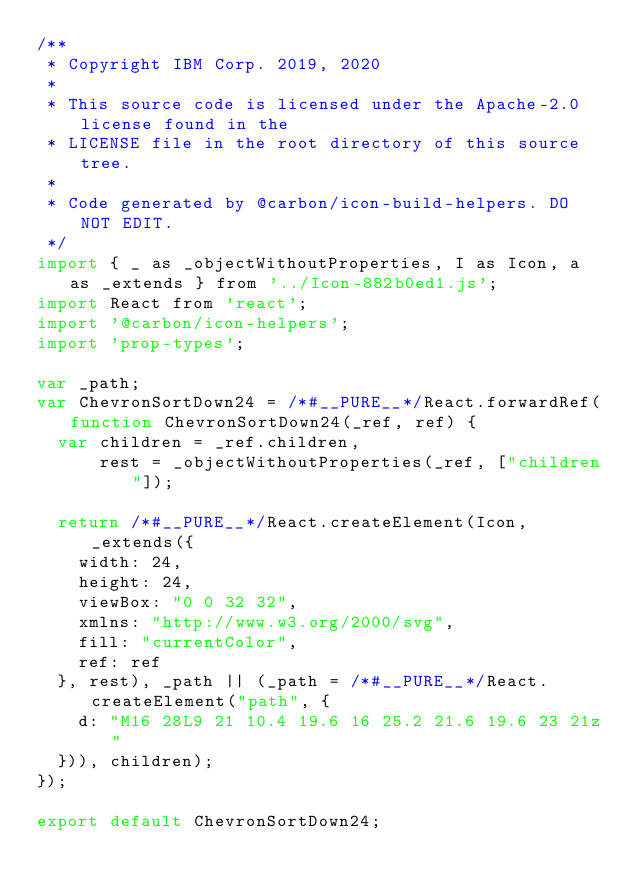Convert code to text. <code><loc_0><loc_0><loc_500><loc_500><_JavaScript_>/**
 * Copyright IBM Corp. 2019, 2020
 *
 * This source code is licensed under the Apache-2.0 license found in the
 * LICENSE file in the root directory of this source tree.
 *
 * Code generated by @carbon/icon-build-helpers. DO NOT EDIT.
 */
import { _ as _objectWithoutProperties, I as Icon, a as _extends } from '../Icon-882b0ed1.js';
import React from 'react';
import '@carbon/icon-helpers';
import 'prop-types';

var _path;
var ChevronSortDown24 = /*#__PURE__*/React.forwardRef(function ChevronSortDown24(_ref, ref) {
  var children = _ref.children,
      rest = _objectWithoutProperties(_ref, ["children"]);

  return /*#__PURE__*/React.createElement(Icon, _extends({
    width: 24,
    height: 24,
    viewBox: "0 0 32 32",
    xmlns: "http://www.w3.org/2000/svg",
    fill: "currentColor",
    ref: ref
  }, rest), _path || (_path = /*#__PURE__*/React.createElement("path", {
    d: "M16 28L9 21 10.4 19.6 16 25.2 21.6 19.6 23 21z"
  })), children);
});

export default ChevronSortDown24;
</code> 